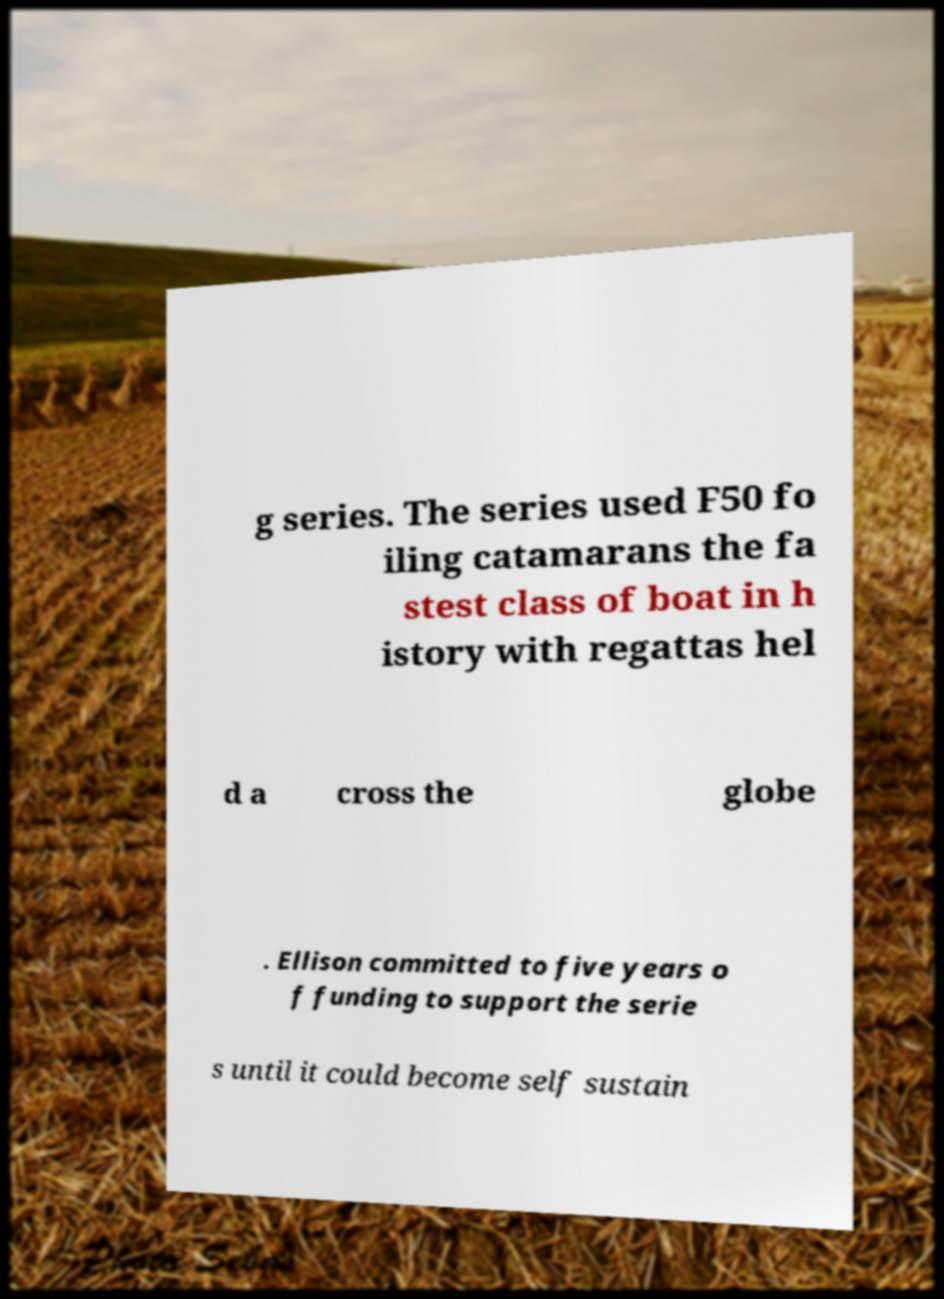Please identify and transcribe the text found in this image. g series. The series used F50 fo iling catamarans the fa stest class of boat in h istory with regattas hel d a cross the globe . Ellison committed to five years o f funding to support the serie s until it could become self sustain 